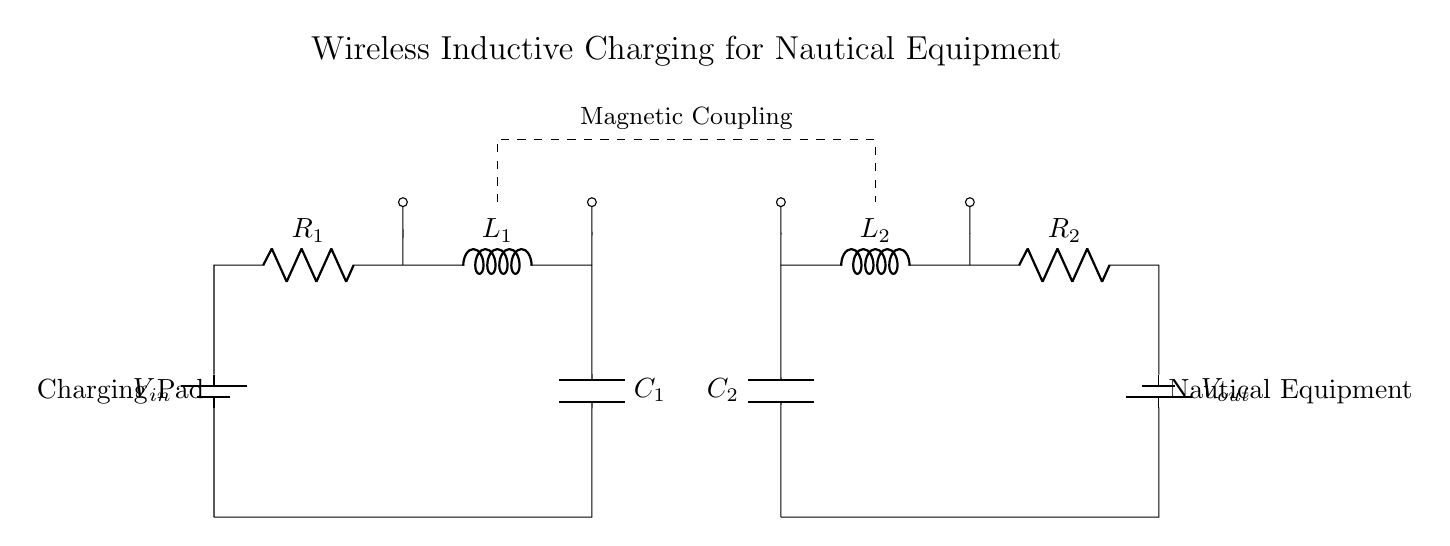What type of circuit is shown? This circuit is a wireless inductive charging circuit, designed for transmitting power without physical connections through a charging pad and a coupled secondary circuit for receiving and converting power for nautical equipment.
Answer: Wireless inductive charging circuit What are the main components identified in the primary circuit? The primary circuit consists of a battery, a resistor, an inductor, and a capacitor, indicated respectively as V_in, R_1, L_1, and C_1 in the diagram.
Answer: Battery, resistor, inductor, capacitor What does the dashed line represent? The dashed line indicates the area of magnetic coupling between the primary and secondary circuits, illustrating how power is transferred wirelessly through inductive coupling.
Answer: Magnetic coupling Which component is used in the secondary circuit to store charge? The capacitor (labeled C_2) is utilized in the secondary circuit for storing charge, which allows it to smoothen the output voltage to the connected nautical equipment.
Answer: Capacitor How many inductors are present in the circuit? The circuit contains two inductors, noted as L_1 in the primary and L_2 in the secondary circuit, which are essential for the process of inductive charging.
Answer: Two What is the function of resistor R_2 in the circuit? Resistor R_2 in the secondary circuit functions to limit the current flowing to the nautical equipment, ensuring that the components receive an appropriate and safe amount of power.
Answer: Limit current What is the voltage supplied by the charging pad? The voltage supplied by the charging pad is denoted as V_in, which represents the input voltage necessary to energize the primary circuit for wireless charging.
Answer: V_in 